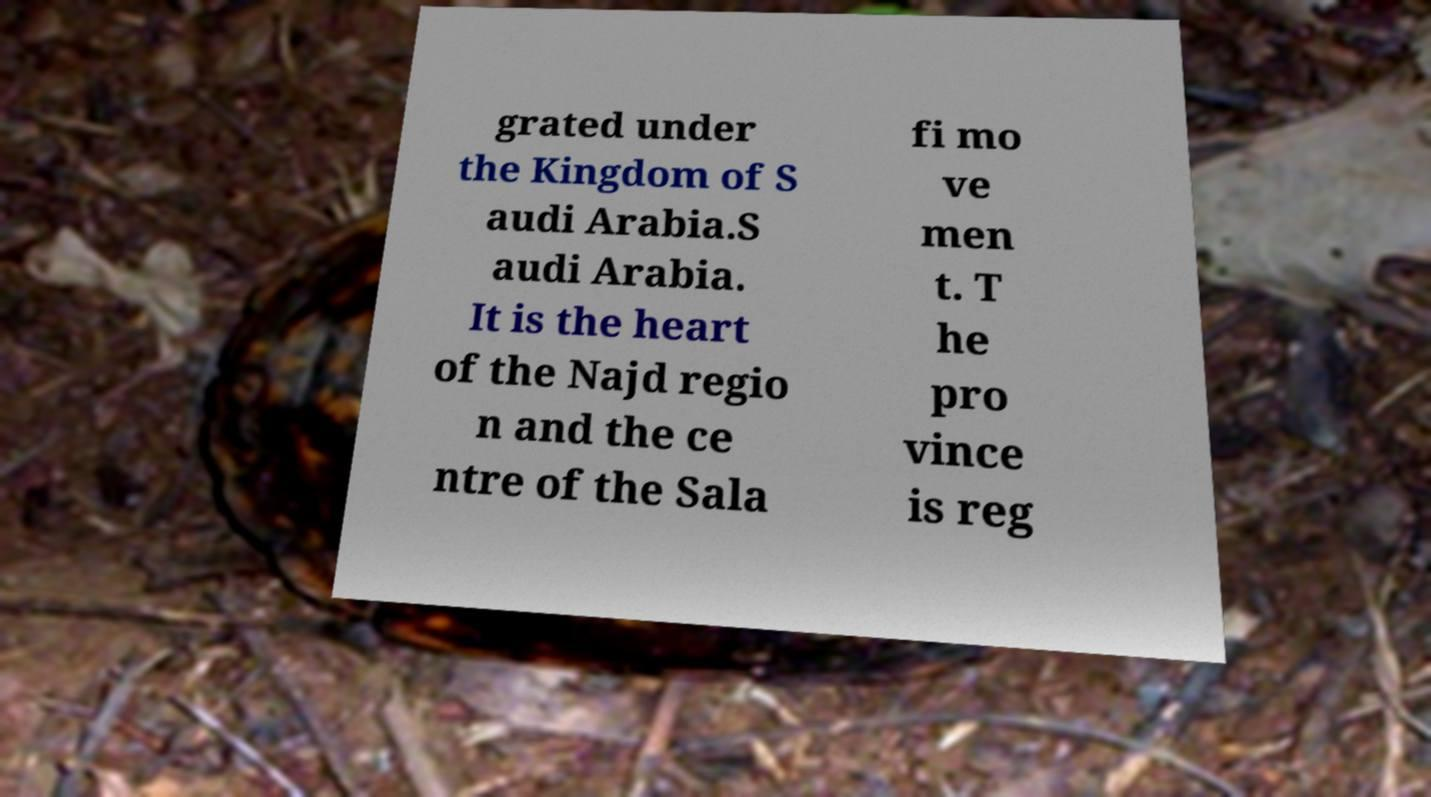I need the written content from this picture converted into text. Can you do that? grated under the Kingdom of S audi Arabia.S audi Arabia. It is the heart of the Najd regio n and the ce ntre of the Sala fi mo ve men t. T he pro vince is reg 